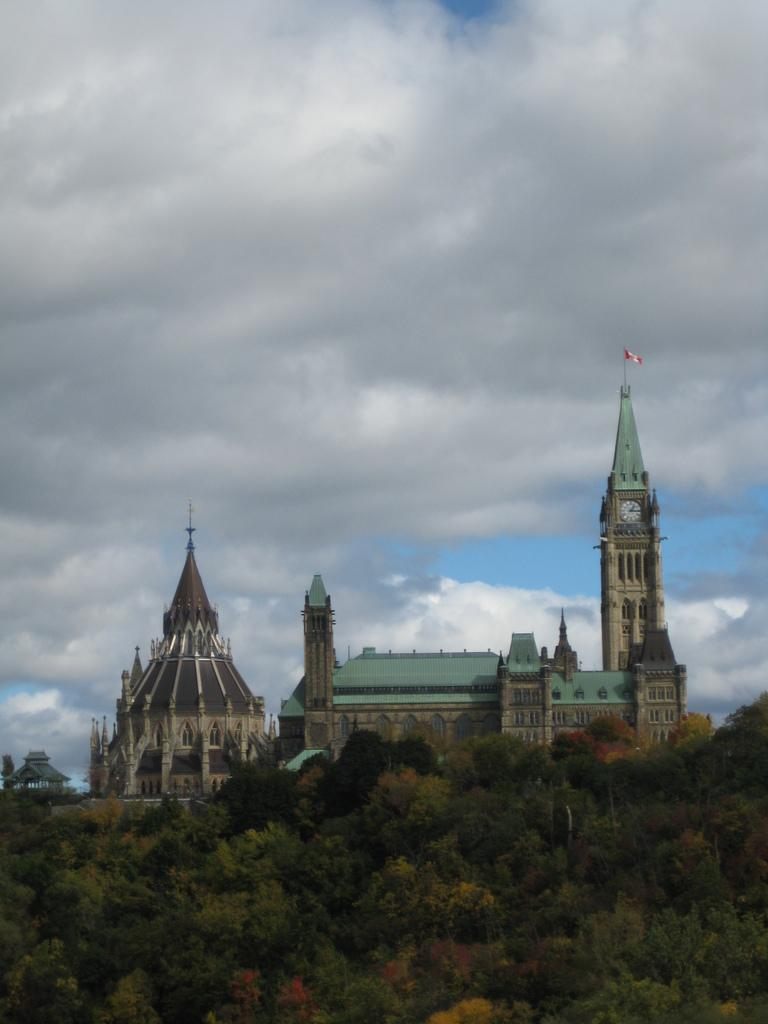What is the main subject in the center of the image? There is a building in the center of the image. What type of natural elements can be seen in the image? There are trees in the image. What can be seen in the background of the image? The sky is visible in the background of the image. Are there any weather conditions depicted in the image? Yes, clouds are present in the background of the image. How many people are getting a haircut in the image? There is no indication of a haircut or people in the image; it features a building, trees, and the sky. What type of headwear is visible on the head of the person walking on the sidewalk? There is no person or sidewalk present in the image. 